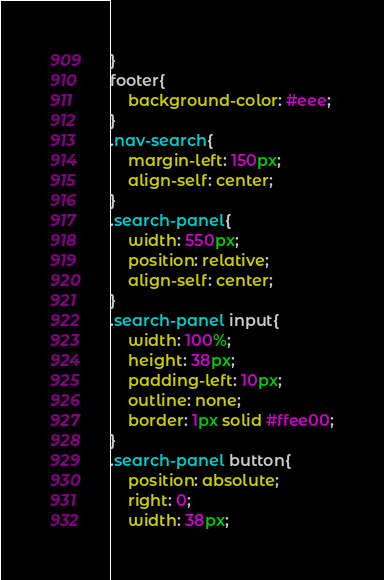<code> <loc_0><loc_0><loc_500><loc_500><_CSS_>}
footer{
    background-color: #eee;
}
.nav-search{
    margin-left: 150px;
    align-self: center;
}
.search-panel{
    width: 550px;
    position: relative;
    align-self: center;
}
.search-panel input{
    width: 100%;
    height: 38px;
    padding-left: 10px;
    outline: none;
    border: 1px solid #ffee00;
}
.search-panel button{
    position: absolute;
    right: 0;
    width: 38px;</code> 